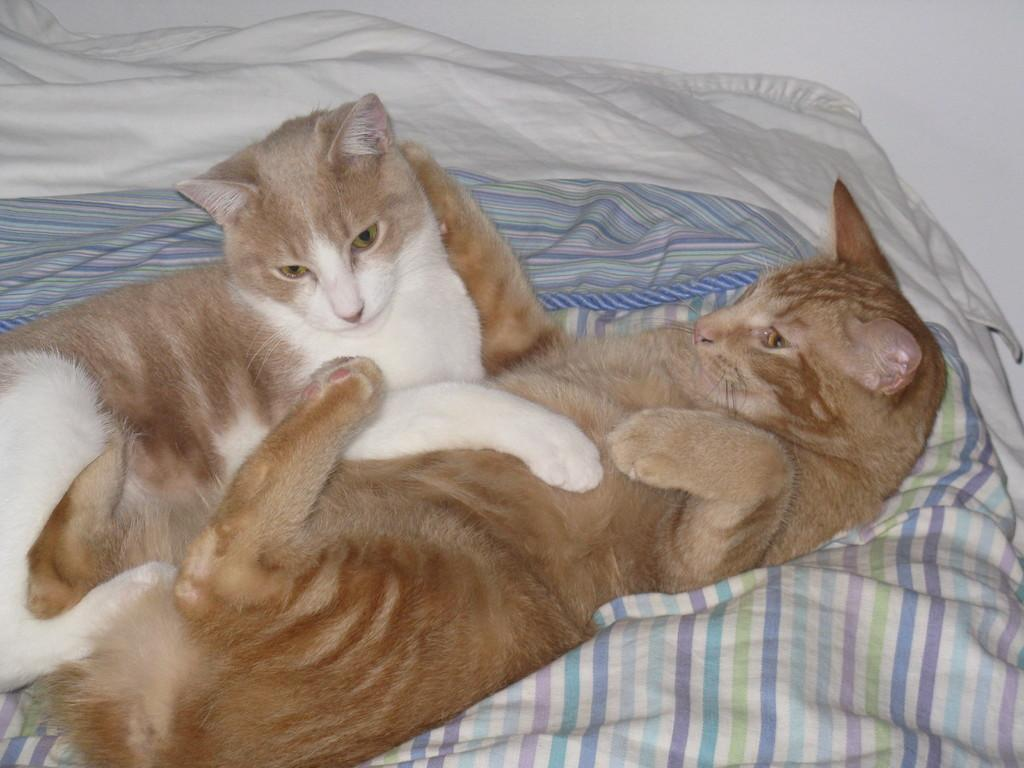How many cats are present in the image? There are two cats in the image. What are the cats doing in the image? The cats are lying on a bed. What type of pizzas can be seen in the image? There are no pizzas present in the image; it features two cats lying on a bed. Can you tell me how many bananas are visible in the image? There are no bananas present in the image. Is there a rifle visible in the image? There is no rifle present in the image. 